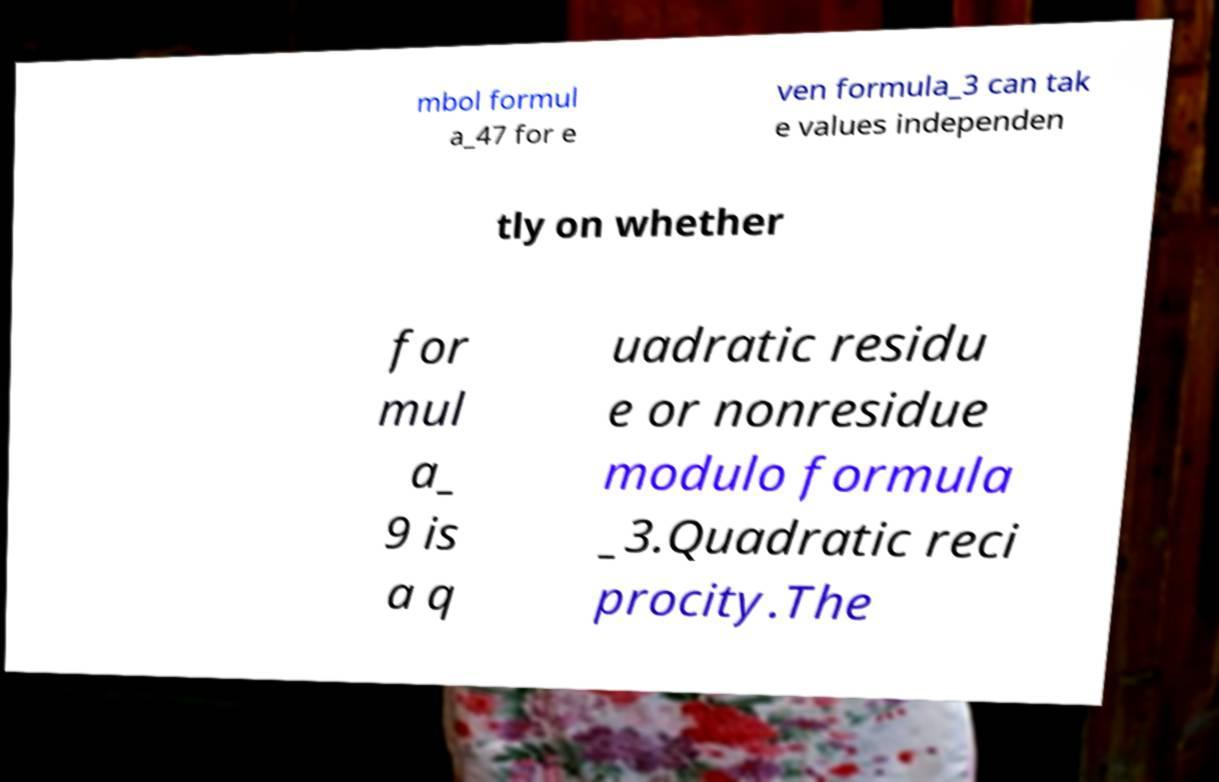Could you assist in decoding the text presented in this image and type it out clearly? mbol formul a_47 for e ven formula_3 can tak e values independen tly on whether for mul a_ 9 is a q uadratic residu e or nonresidue modulo formula _3.Quadratic reci procity.The 